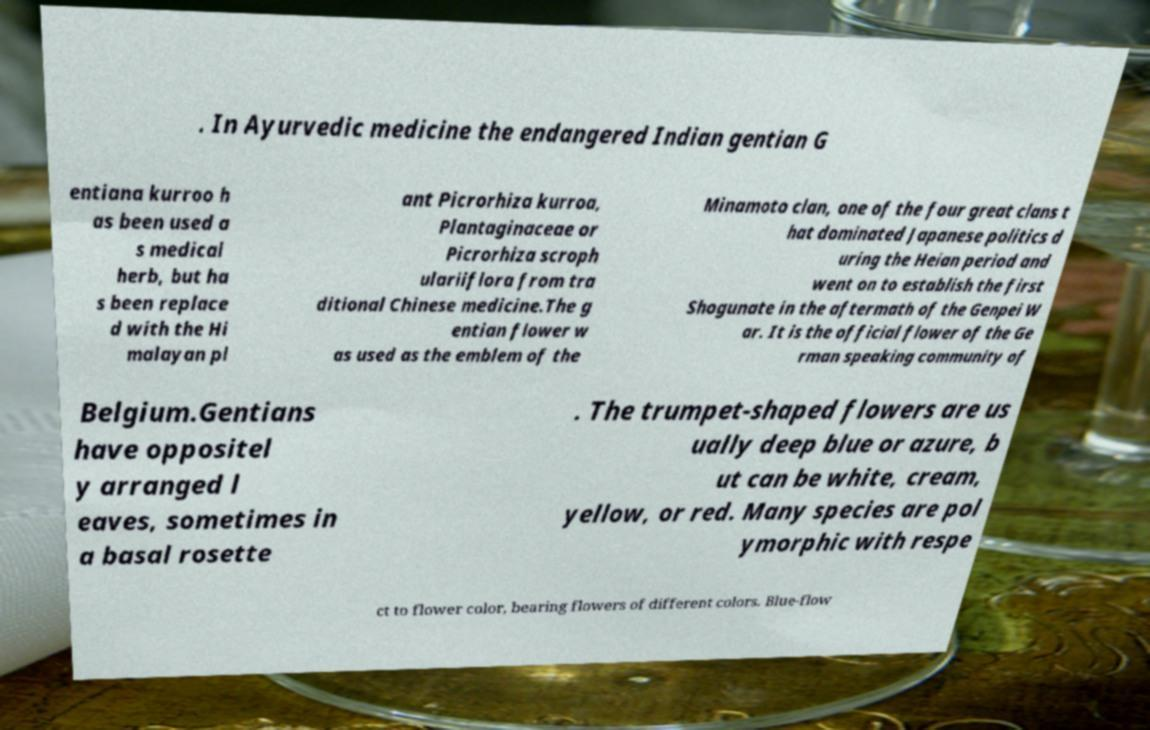Can you accurately transcribe the text from the provided image for me? . In Ayurvedic medicine the endangered Indian gentian G entiana kurroo h as been used a s medical herb, but ha s been replace d with the Hi malayan pl ant Picrorhiza kurroa, Plantaginaceae or Picrorhiza scroph ulariiflora from tra ditional Chinese medicine.The g entian flower w as used as the emblem of the Minamoto clan, one of the four great clans t hat dominated Japanese politics d uring the Heian period and went on to establish the first Shogunate in the aftermath of the Genpei W ar. It is the official flower of the Ge rman speaking community of Belgium.Gentians have oppositel y arranged l eaves, sometimes in a basal rosette . The trumpet-shaped flowers are us ually deep blue or azure, b ut can be white, cream, yellow, or red. Many species are pol ymorphic with respe ct to flower color, bearing flowers of different colors. Blue-flow 